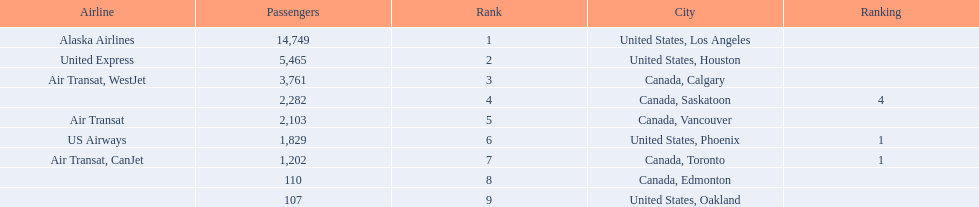Where are the destinations of the airport? United States, Los Angeles, United States, Houston, Canada, Calgary, Canada, Saskatoon, Canada, Vancouver, United States, Phoenix, Canada, Toronto, Canada, Edmonton, United States, Oakland. What is the number of passengers to phoenix? 1,829. 